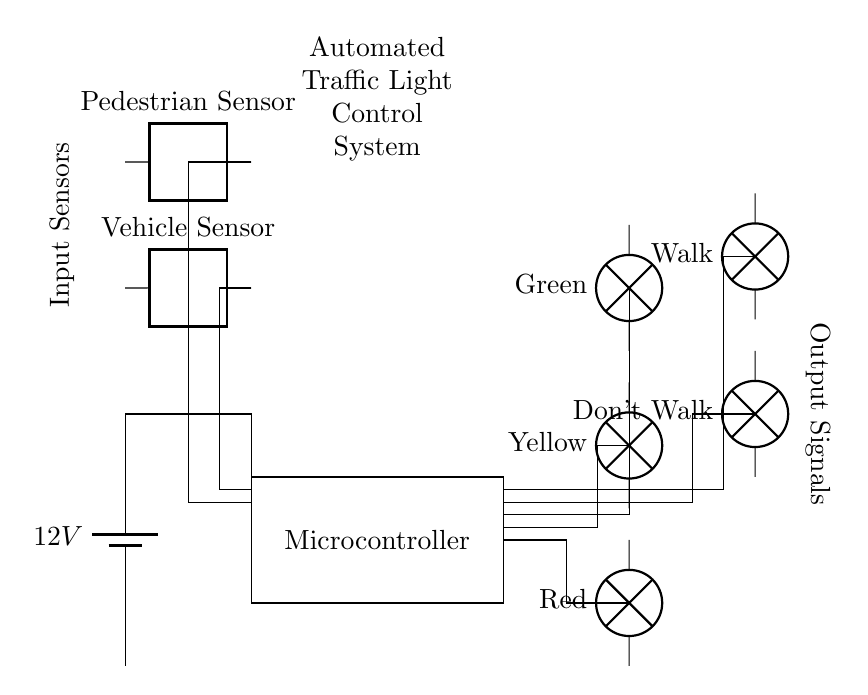What is the main power supply voltage in the circuit? The voltage is 12V, clearly indicated next to the battery in the circuit diagram.
Answer: 12V What components are used for sensing in this traffic light control system? The circuit diagram includes two sensors: a Vehicle Sensor and a Pedestrian Sensor, both of which are drawn at the top of the diagram.
Answer: Vehicle Sensor, Pedestrian Sensor How many traffic lights are represented in the circuit? There are three traffic lights depicted: Red, Yellow, and Green, arranged vertically on the right side of the diagram.
Answer: Three What type of output signals are shown for pedestrians in the circuit? The output signals for pedestrians include a "Don't Walk" signal and a "Walk" signal, indicated with labels next to the corresponding lights.
Answer: Don't Walk, Walk What is the purpose of the microcontroller in this circuit? The microcontroller processes inputs from the sensors to control the traffic lights and pedestrian signals, as indicated by its label and connections to other components.
Answer: Control How does the circuit indicate the flow of current? Current flow is indicated by the drawing arrows, which show the direction from the battery through the microcontroller and then to the output lights. This flow path can be traced through the connections in the diagram.
Answer: Through arrows in connections What is the relationship between the sensors and the microcontroller in this system? The sensors provide input signals to the microcontroller, which processes these inputs to manage the output signals for the traffic and pedestrian lights, demonstrated by the lines connecting them in the diagram.
Answer: Input and control 